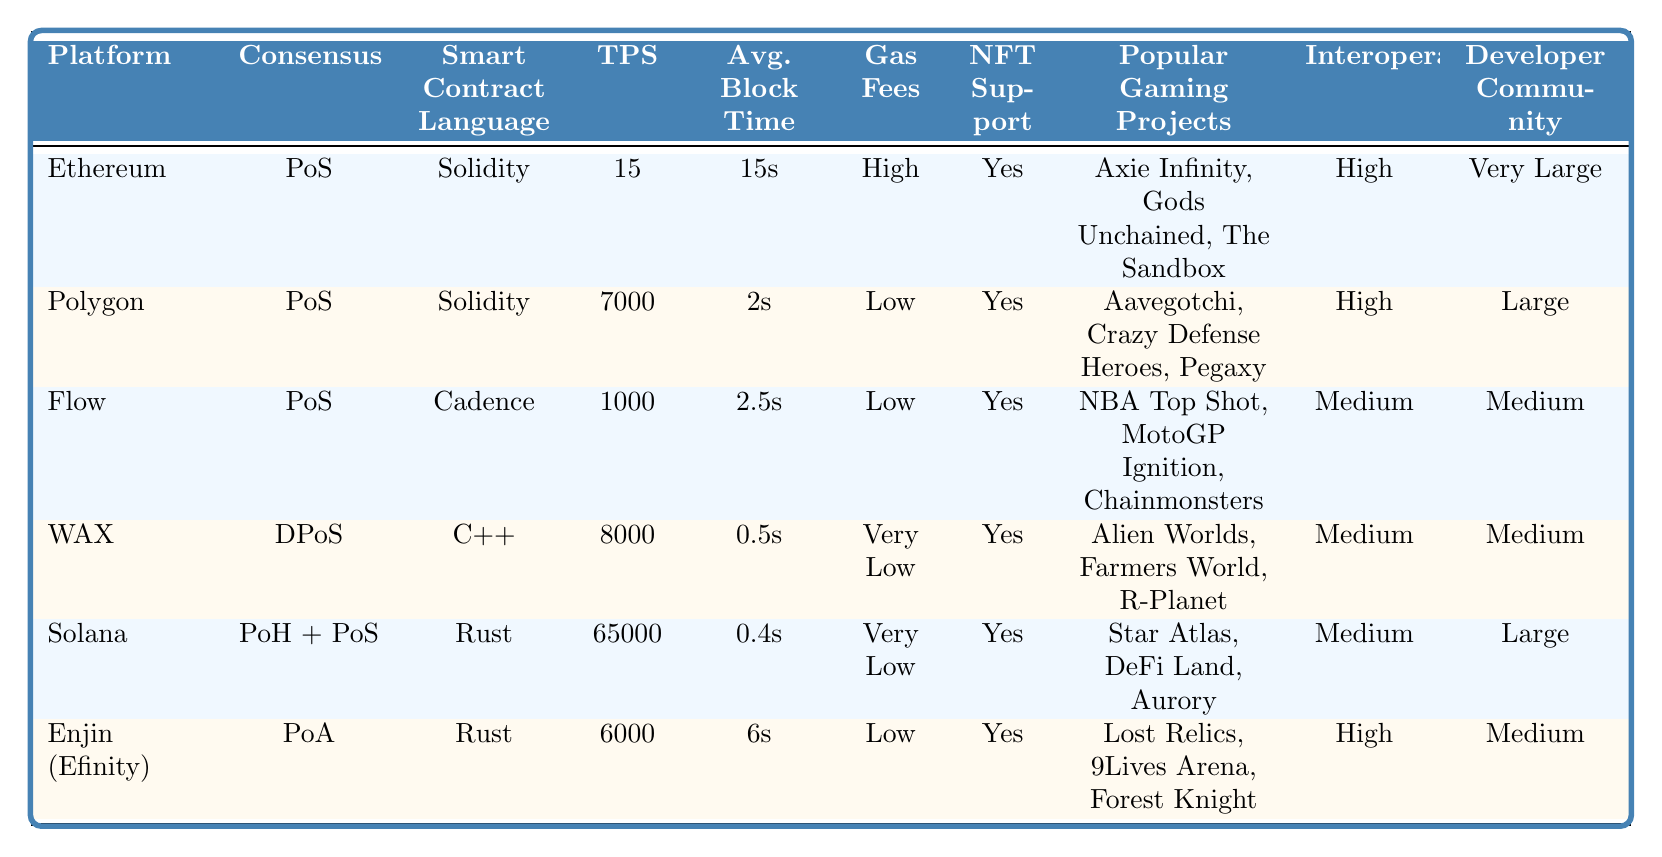What is the consensus mechanism used by the Solana platform? The table lists the consensus mechanism for each platform, and for Solana, it is listed as "Proof of History + Proof of Stake".
Answer: Proof of History + Proof of Stake Which platform has the highest Transactions Per Second (TPS)? In the table, the TPS for each platform is noted, and Solana has the highest TPS at 65,000.
Answer: Solana Does Ethereum support NFTs? By looking at the row for Ethereum, it is indicated that NFT support is marked as "Yes".
Answer: Yes What is the average block time for the Polygon platform? The average block time for Polygon is shown as "2 seconds" in the corresponding row.
Answer: 2 seconds Which blockchain platform has the lowest gas fees? The gas fees are compared in the table, and WAX and Solana both have "Very Low" listed. WAX has a different classification, but both represent the lowest category.
Answer: WAX and Solana Are all the platforms using the same smart contract language? Each platform has a specific smart contract language mentioned; the languages vary (e.g., Solidity, Cadence, C++). This indicates not all platforms use the same language.
Answer: No What is the difference in average block time between WAX and Flow? WAX has an average block time of 0.5 seconds, and Flow has 2.5 seconds. To find the difference: 2.5s - 0.5s = 2 seconds.
Answer: 2 seconds How many popular gaming projects are listed for Solana? The row for Solana shows three popular gaming projects: Star Atlas, DeFi Land, and Aurory which count as three.
Answer: 3 If you were to rank the platforms by average block time from fastest to slowest, which one would be ranked second? The average block times are 0.4 (Solana), 0.5 (WAX), 2 (Polygon), 2.5 (Flow), and 6 seconds (Enjin). Therefore, WAX would be the second fastest.
Answer: WAX Which two platforms have the largest developer community size? The developer community sizes noted are: Very Large (Ethereum), Large (Solana), Large (Polygon), Medium (Flow and WAX), Medium (Enjin). The two with the largest community are Ethereum and Solana.
Answer: Ethereum and Solana 